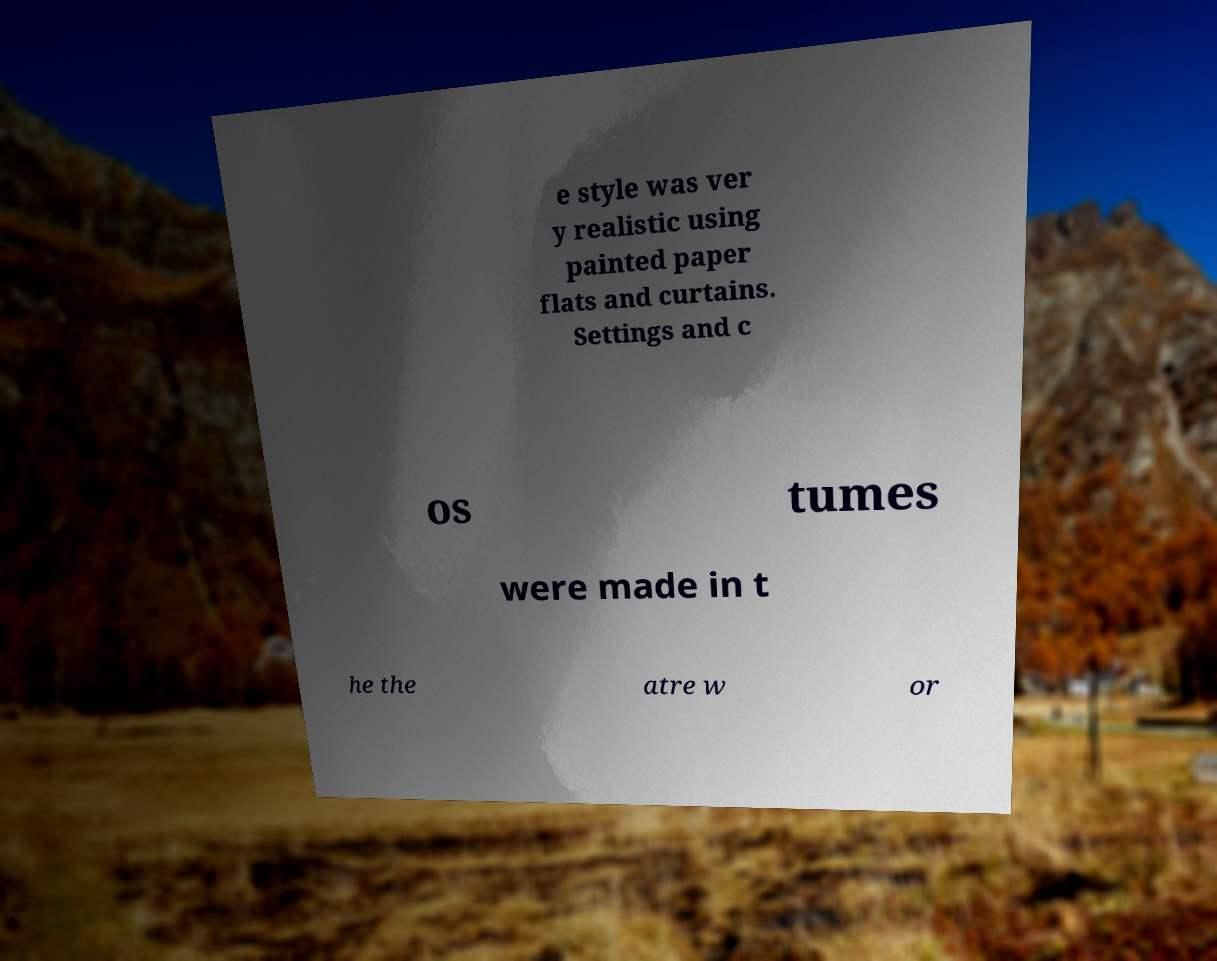Can you read and provide the text displayed in the image?This photo seems to have some interesting text. Can you extract and type it out for me? e style was ver y realistic using painted paper flats and curtains. Settings and c os tumes were made in t he the atre w or 